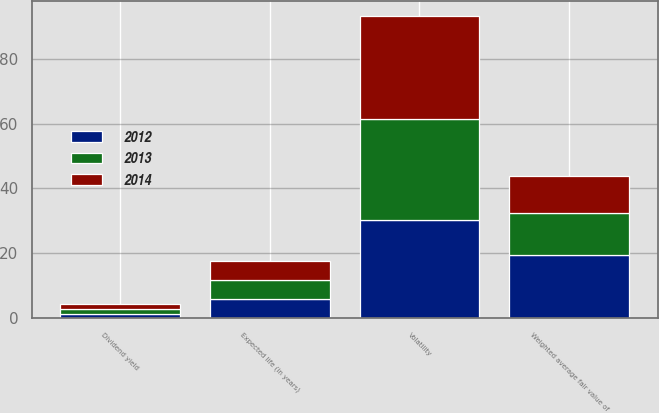Convert chart to OTSL. <chart><loc_0><loc_0><loc_500><loc_500><stacked_bar_chart><ecel><fcel>Weighted average fair value of<fcel>Dividend yield<fcel>Volatility<fcel>Expected life (in years)<nl><fcel>2012<fcel>19.52<fcel>1.27<fcel>30.36<fcel>5.89<nl><fcel>2013<fcel>12.97<fcel>1.57<fcel>30.92<fcel>5.86<nl><fcel>2014<fcel>11.4<fcel>1.59<fcel>32<fcel>5.98<nl></chart> 